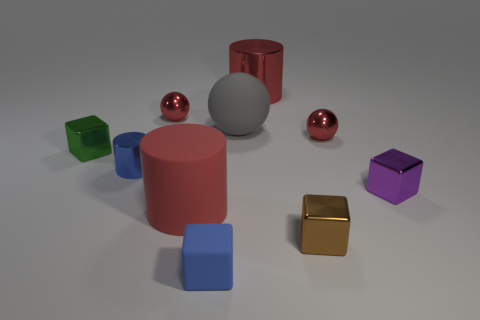What is the color of the big cylinder that is behind the tiny red metallic object right of the large gray thing that is right of the small blue shiny cylinder?
Provide a succinct answer. Red. There is a brown object that is the same size as the rubber block; what is its material?
Make the answer very short. Metal. What number of things are small shiny blocks right of the tiny cylinder or tiny shiny cylinders?
Keep it short and to the point. 3. Are there any big blue spheres?
Offer a very short reply. No. There is a large red cylinder behind the green thing; what material is it?
Keep it short and to the point. Metal. There is another cylinder that is the same color as the big rubber cylinder; what is its material?
Offer a terse response. Metal. What number of large things are shiny spheres or cylinders?
Your answer should be compact. 2. The small matte block has what color?
Your response must be concise. Blue. Are there any shiny spheres that are on the right side of the metallic cylinder behind the tiny blue cylinder?
Your answer should be very brief. Yes. Are there fewer small shiny blocks on the right side of the tiny green block than tiny rubber objects?
Your answer should be very brief. No. 